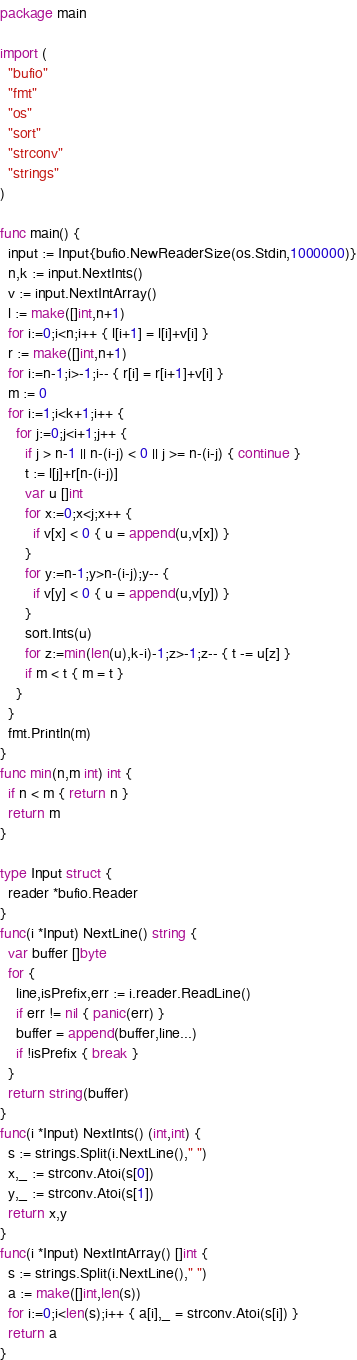<code> <loc_0><loc_0><loc_500><loc_500><_Go_>package main

import (
  "bufio"
  "fmt"
  "os"
  "sort"
  "strconv"
  "strings"
)

func main() {
  input := Input{bufio.NewReaderSize(os.Stdin,1000000)}
  n,k := input.NextInts()
  v := input.NextIntArray()
  l := make([]int,n+1)
  for i:=0;i<n;i++ { l[i+1] = l[i]+v[i] }
  r := make([]int,n+1)
  for i:=n-1;i>-1;i-- { r[i] = r[i+1]+v[i] }
  m := 0
  for i:=1;i<k+1;i++ {
    for j:=0;j<i+1;j++ {
      if j > n-1 || n-(i-j) < 0 || j >= n-(i-j) { continue }
      t := l[j]+r[n-(i-j)]
      var u []int
      for x:=0;x<j;x++ {
        if v[x] < 0 { u = append(u,v[x]) }
      }
      for y:=n-1;y>n-(i-j);y-- {
        if v[y] < 0 { u = append(u,v[y]) }
      }
      sort.Ints(u)
      for z:=min(len(u),k-i)-1;z>-1;z-- { t -= u[z] }
      if m < t { m = t }
    }
  }
  fmt.Println(m)
}
func min(n,m int) int {
  if n < m { return n }
  return m
}

type Input struct {
  reader *bufio.Reader
}
func(i *Input) NextLine() string {
  var buffer []byte
  for {
    line,isPrefix,err := i.reader.ReadLine()
    if err != nil { panic(err) }
    buffer = append(buffer,line...)
    if !isPrefix { break }
  }
  return string(buffer)
}
func(i *Input) NextInts() (int,int) {
  s := strings.Split(i.NextLine()," ")
  x,_ := strconv.Atoi(s[0])
  y,_ := strconv.Atoi(s[1])
  return x,y
}
func(i *Input) NextIntArray() []int {
  s := strings.Split(i.NextLine()," ")
  a := make([]int,len(s))
  for i:=0;i<len(s);i++ { a[i],_ = strconv.Atoi(s[i]) }
  return a
}</code> 